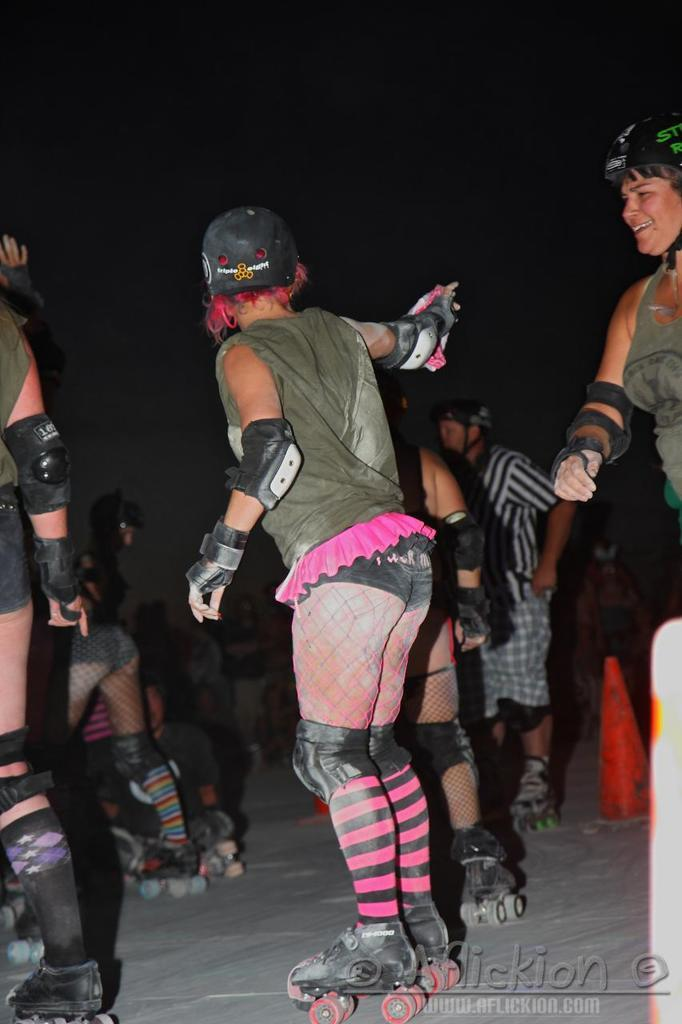What is happening in the image involving a group of people? The people in the image are skating. What are the people wearing on their heads? The people are wearing helmets. What color are the dresses worn by the people in the image? The people are wearing green color dresses. How would you describe the lighting in the image? The image is a little dark. Can you see any rail tracks in the image? There are no rail tracks visible in the image. What type of sea creatures can be seen swimming in the image? There are no sea creatures present in the image. 